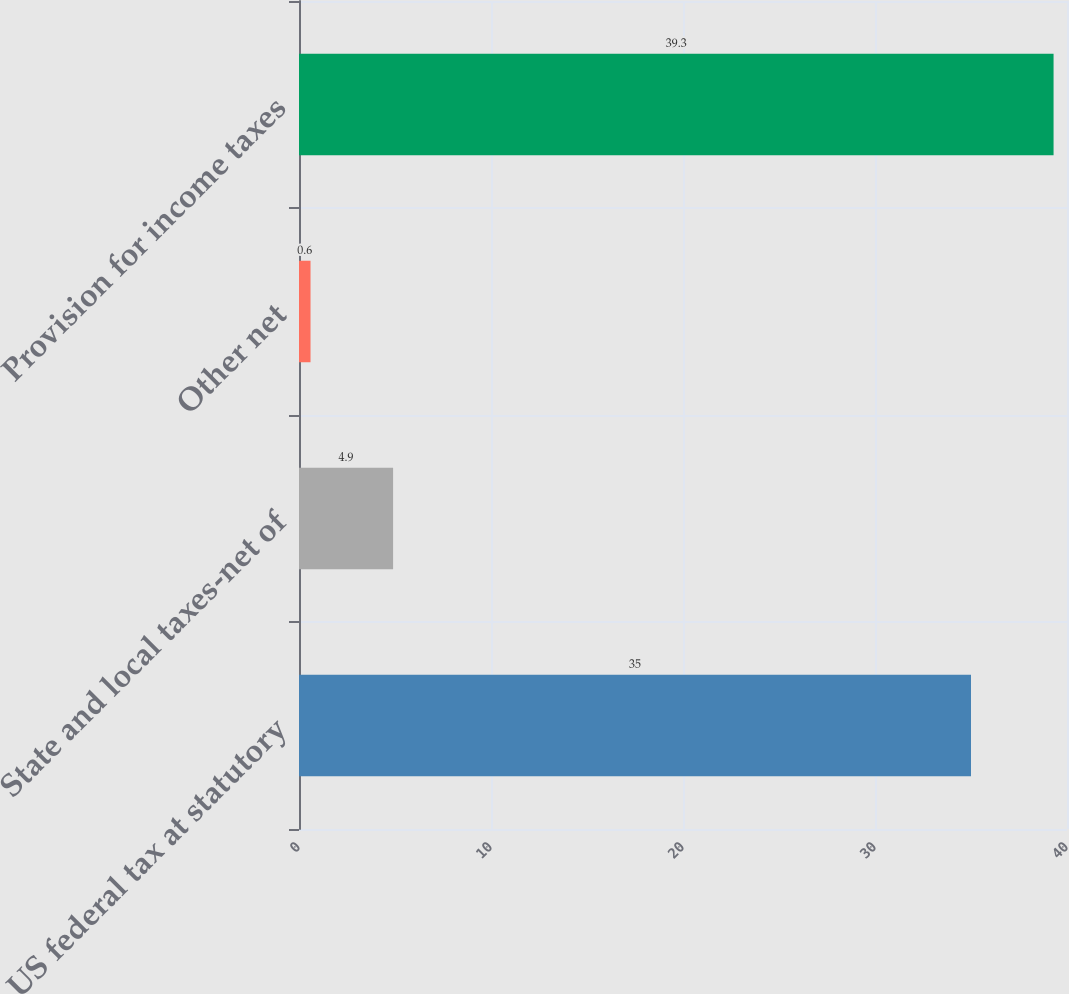Convert chart. <chart><loc_0><loc_0><loc_500><loc_500><bar_chart><fcel>US federal tax at statutory<fcel>State and local taxes-net of<fcel>Other net<fcel>Provision for income taxes<nl><fcel>35<fcel>4.9<fcel>0.6<fcel>39.3<nl></chart> 